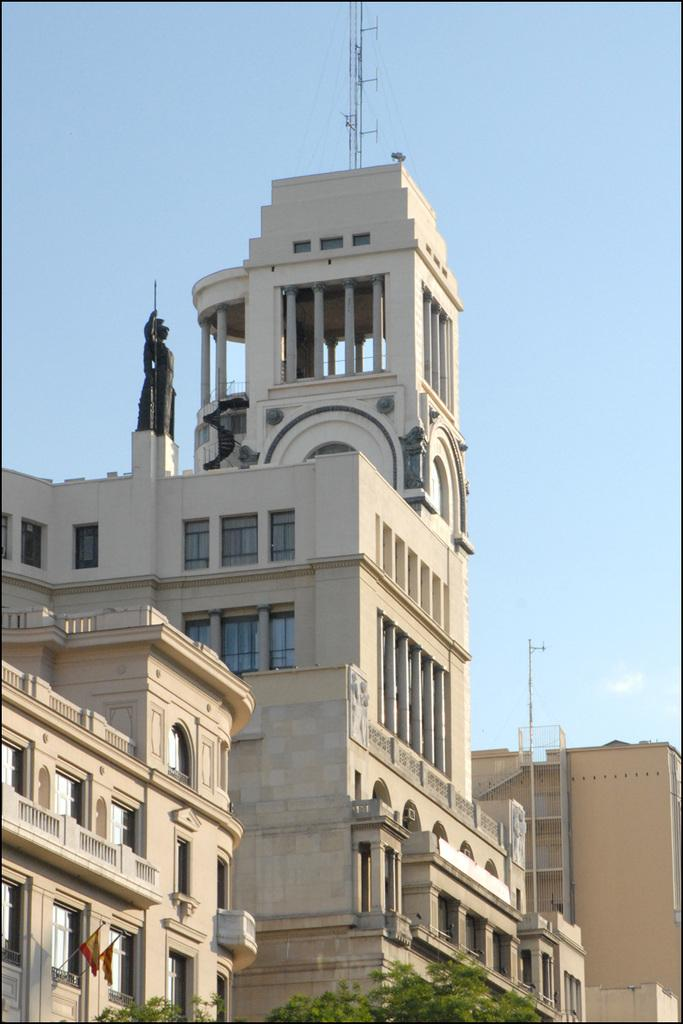What type of structures are present in the image? There are buildings in the image. What feature can be seen on the buildings? The buildings have windows. What color is the sky in the image? The sky is blue at the top of the image. Where is the toad located in the image? There is no toad present in the image. What word is written on the stop sign in the image? There is no stop sign present in the image. 